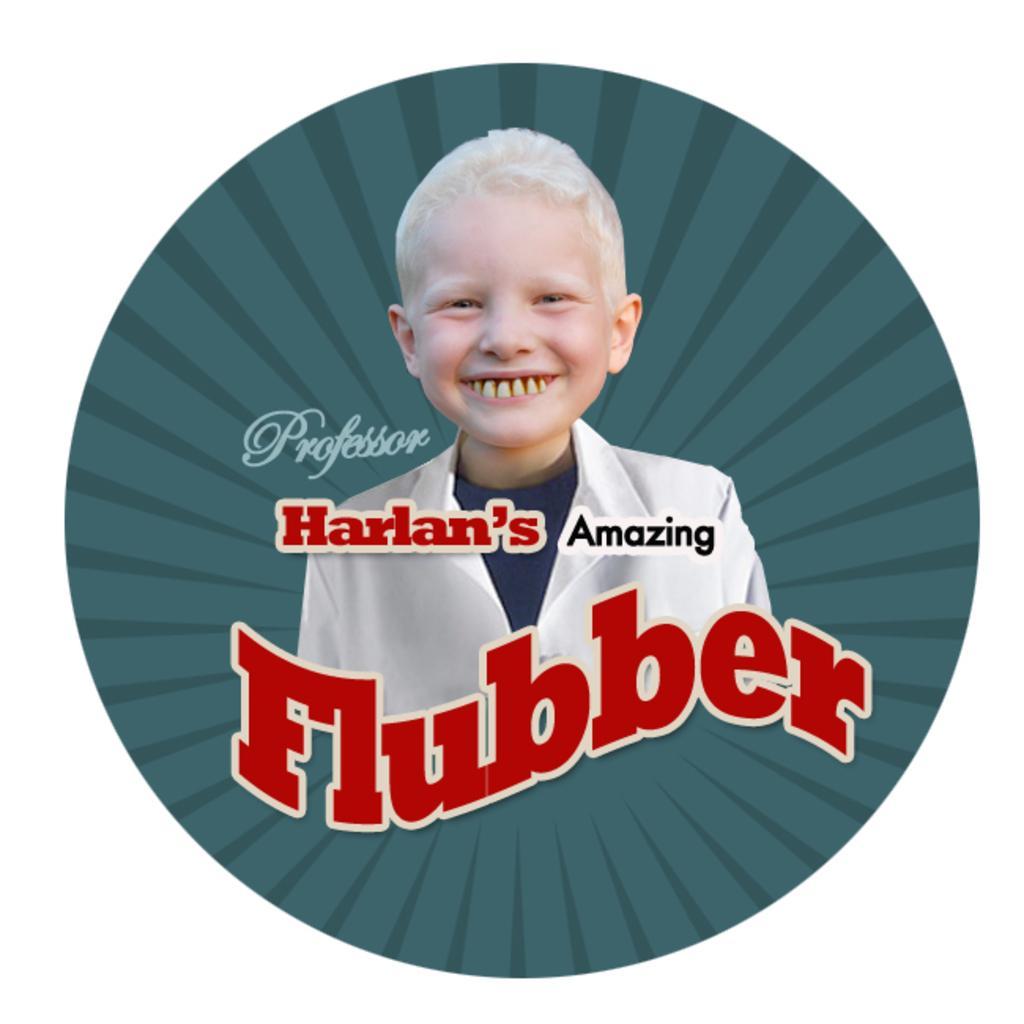Describe this image in one or two sentences. This is a poster. In the center of the picture there is a kid smiling. On the poster there is text. The poster has green background. 